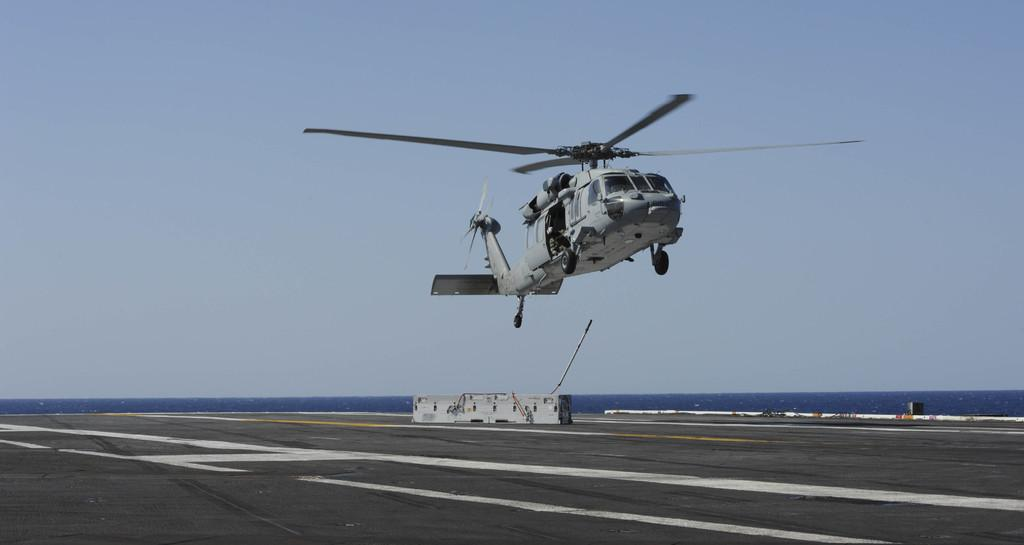What is flying in the sky in the image? There is a helicopter in the sky in the image. What can be seen on the ground in the image? There is a runway visible in the image. What type of natural feature is present in the image? There is a large water body in the image. What type of ear is visible on the helicopter in the image? There are no ears visible on the helicopter in the image, as helicopters do not have ears. 